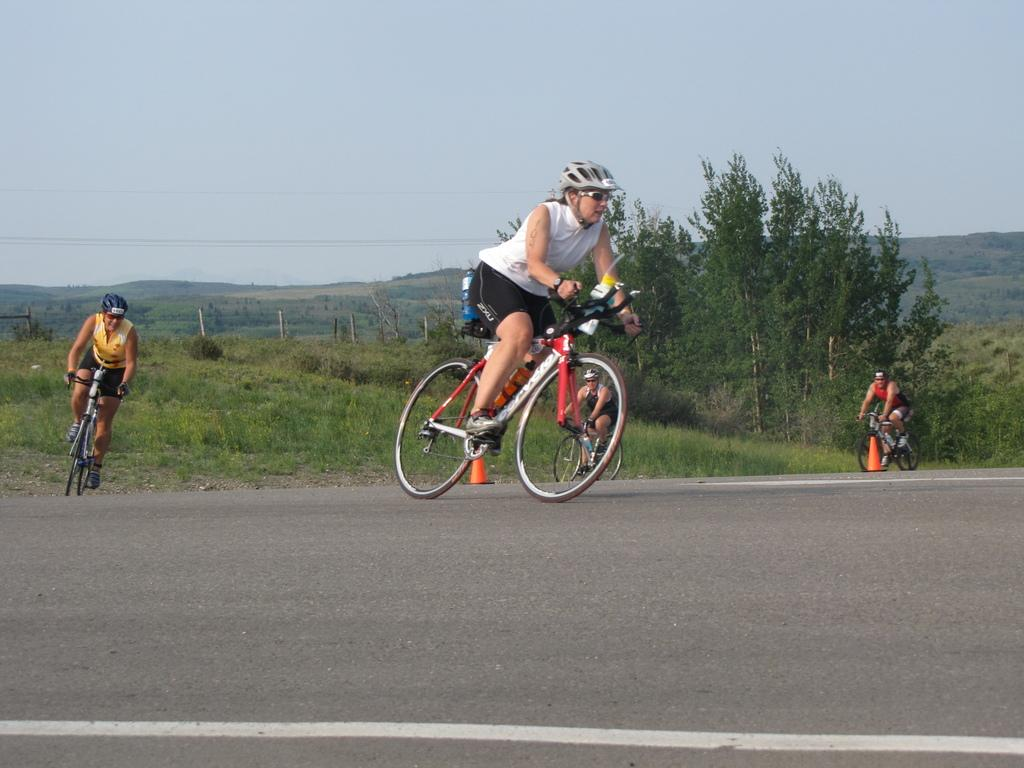What are the people in the image doing? The people in the image are riding bicycles. What can be seen in the background of the image? There are trees, hills, and the sky visible in the background of the image. What might be used to direct traffic or indicate a hazard in the image? Traffic cones are present in the image. What type of coil is being used to support the trees in the image? There is no coil present in the image, and the trees are not being supported by any coil. 